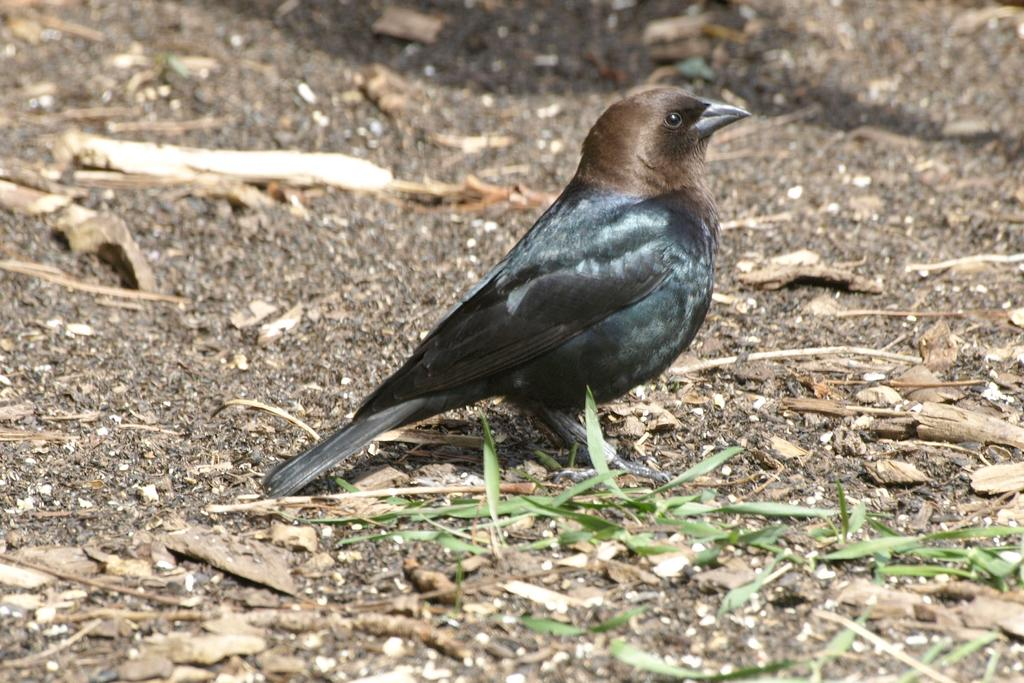What is the main subject in the foreground of the image? There is a bird in the foreground of the image. Where is the bird located? The bird is on the ground. What else can be seen on the ground in the image? There are wooden sticks and leaves visible on the ground. What type of whip can be seen in the image? There is no whip present in the image. Can you tell me how many books are in the library depicted in the image? There is no library depicted in the image. 